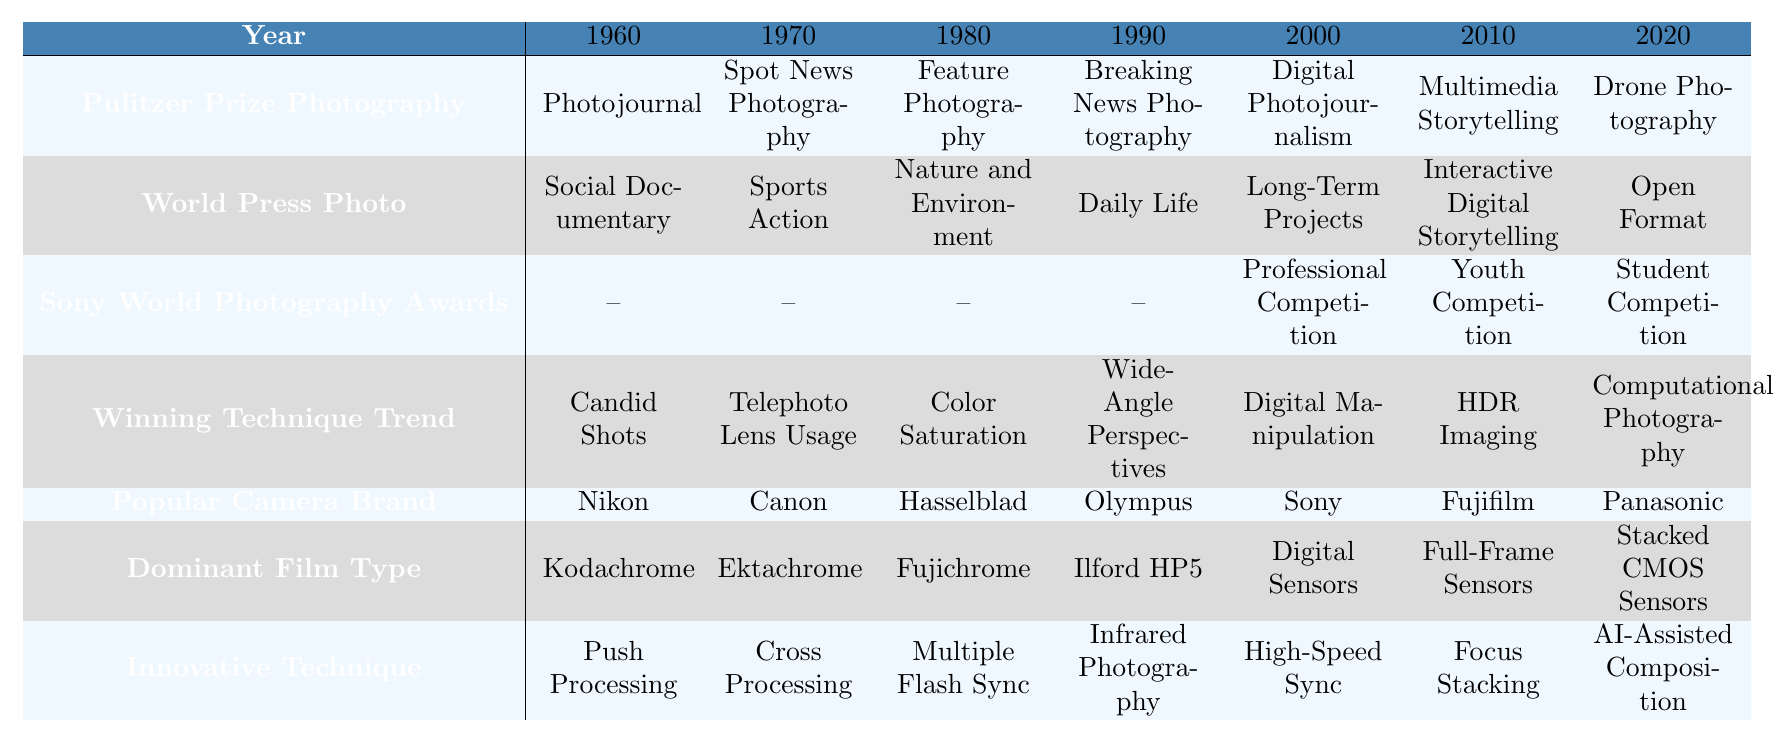What photography category was recognized in 1980 at the Pulitzer Prize? The table indicates that "Feature Photography" won the Pulitzer Prize in 1980.
Answer: Feature Photography Which winning technique trend emerged in 2010? The table shows that "HDR Imaging" was the winning technique trend in 2010.
Answer: HDR Imaging Was "Infrared Photography" an innovative technique recognized in the 1990s? The table lists "Infrared Photography" under innovative techniques, which corresponds to the year 1990, so the answer is yes.
Answer: Yes Can you identify a popular camera brand used in 2000? The table indicates that "Sony" was a popular camera brand in 2000.
Answer: Sony Compare the Pulitzer Prize photography category of 1970 with that of 2020. In 1970, the category was "Spot News Photography," while in 2020 it was "Drone Photography." This shows a shift from traditional to modern techniques.
Answer: Spot News Photography and Drone Photography What innovative technique was predominantly used in the 2000s? The table lists "Digital Manipulation" as the innovative technique for the year 2000.
Answer: Digital Manipulation Which technique trend is most recent according to the table? The latest winning technique documented in the table is "Computational Photography," corresponding to the year 2020.
Answer: Computational Photography Is the Sony World Photography Awards category for 1960 specified in the table? The table shows "--" for the Sony World Photography Awards in 1960, indicating there was no specified category then.
Answer: No Determine the dominant film type over the decades shown for 1990 and 2020. The dominant film type in 1990 was "Ilford HP5," while in 2020 it was "Stacked CMOS Sensors," indicating a transition from analog to digital.
Answer: Ilford HP5 and Stacked CMOS Sensors What change in winning technique is observed from 2000 to 2010? The winning technique trend shifted from "Digital Manipulation" in 2000 to "HDR Imaging" in 2010, showing an evolution in digital photography techniques.
Answer: From Digital Manipulation to HDR Imaging 